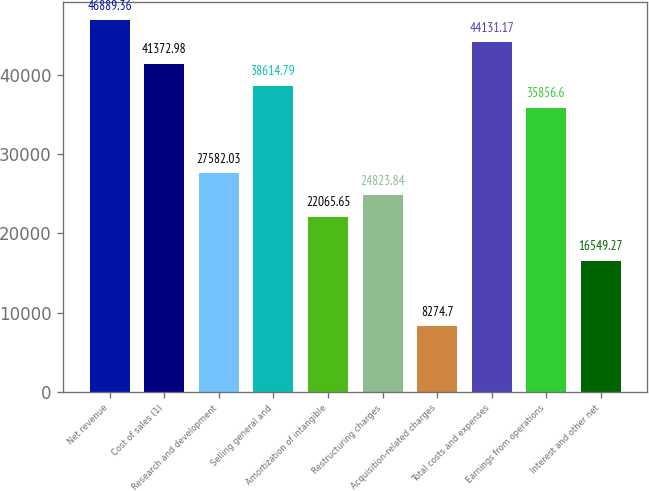Convert chart. <chart><loc_0><loc_0><loc_500><loc_500><bar_chart><fcel>Net revenue<fcel>Cost of sales (1)<fcel>Research and development<fcel>Selling general and<fcel>Amortization of intangible<fcel>Restructuring charges<fcel>Acquisition-related charges<fcel>Total costs and expenses<fcel>Earnings from operations<fcel>Interest and other net<nl><fcel>46889.4<fcel>41373<fcel>27582<fcel>38614.8<fcel>22065.7<fcel>24823.8<fcel>8274.7<fcel>44131.2<fcel>35856.6<fcel>16549.3<nl></chart> 